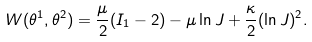<formula> <loc_0><loc_0><loc_500><loc_500>W ( \theta ^ { 1 } , \theta ^ { 2 } ) = \frac { \mu } { 2 } ( I _ { 1 } - 2 ) - \mu \ln J + \frac { \kappa } { 2 } ( \ln J ) ^ { 2 } .</formula> 